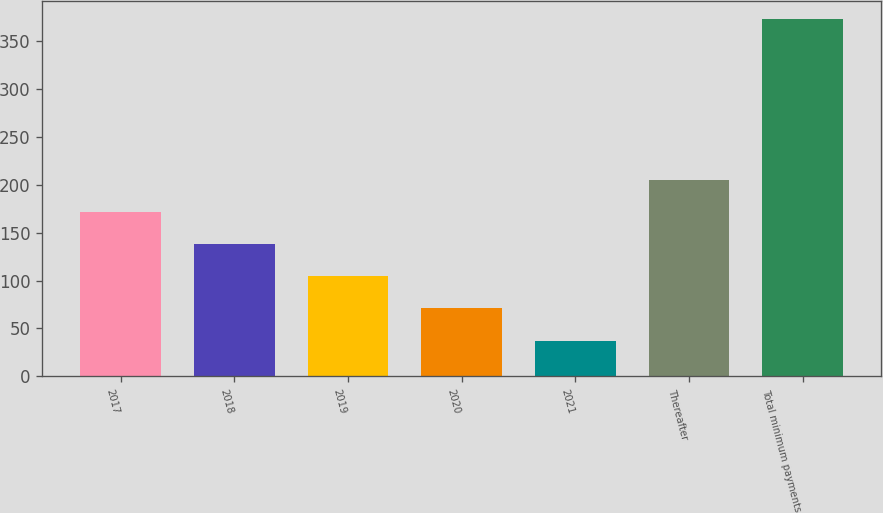Convert chart to OTSL. <chart><loc_0><loc_0><loc_500><loc_500><bar_chart><fcel>2017<fcel>2018<fcel>2019<fcel>2020<fcel>2021<fcel>Thereafter<fcel>Total minimum payments<nl><fcel>171.74<fcel>138.13<fcel>104.52<fcel>70.91<fcel>37.3<fcel>205.35<fcel>373.4<nl></chart> 